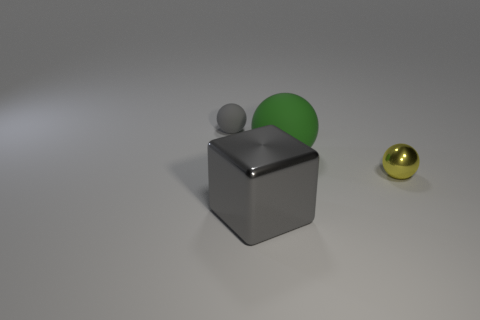There is a yellow shiny object that is the same shape as the tiny gray rubber object; what is its size?
Your answer should be compact. Small. Is there a large gray thing made of the same material as the tiny yellow sphere?
Offer a very short reply. Yes. There is a gray thing left of the gray metallic thing; is its shape the same as the large gray object?
Give a very brief answer. No. How many small gray spheres are right of the block in front of the tiny thing on the left side of the gray cube?
Give a very brief answer. 0. Are there fewer small rubber things that are right of the metallic block than tiny objects that are behind the yellow shiny ball?
Offer a very short reply. Yes. There is another matte object that is the same shape as the large green matte thing; what is its color?
Offer a terse response. Gray. How big is the green matte sphere?
Your response must be concise. Large. How many blocks have the same size as the shiny ball?
Your answer should be compact. 0. Does the big cube have the same color as the tiny matte thing?
Your answer should be very brief. Yes. Are the small object that is behind the small yellow thing and the large object that is behind the yellow metallic object made of the same material?
Offer a very short reply. Yes. 